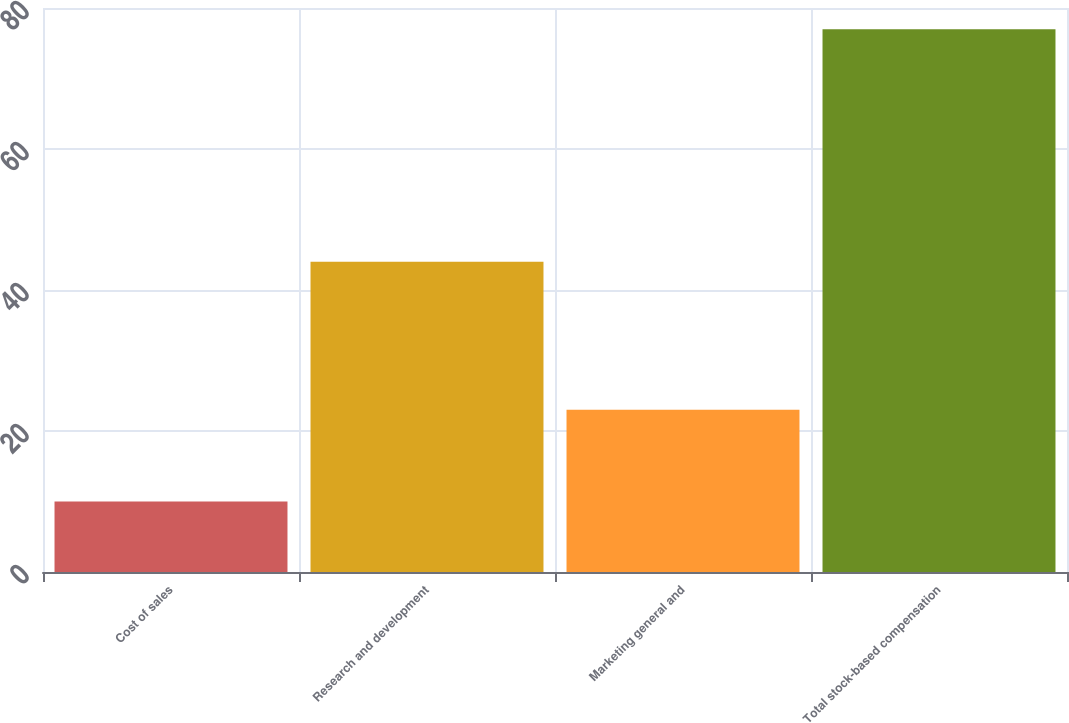Convert chart to OTSL. <chart><loc_0><loc_0><loc_500><loc_500><bar_chart><fcel>Cost of sales<fcel>Research and development<fcel>Marketing general and<fcel>Total stock-based compensation<nl><fcel>10<fcel>44<fcel>23<fcel>77<nl></chart> 